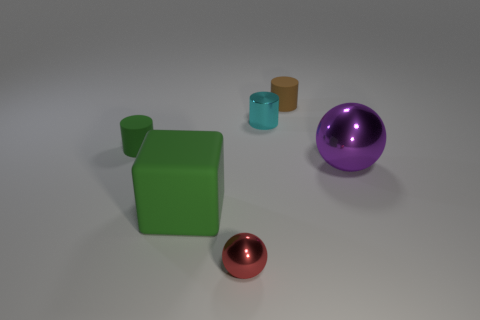Subtract 1 cylinders. How many cylinders are left? 2 Subtract all small rubber cylinders. How many cylinders are left? 1 Add 1 big shiny balls. How many objects exist? 7 Subtract all balls. How many objects are left? 4 Subtract 0 yellow cylinders. How many objects are left? 6 Subtract all big cyan metal balls. Subtract all small matte objects. How many objects are left? 4 Add 6 matte cubes. How many matte cubes are left? 7 Add 2 metal spheres. How many metal spheres exist? 4 